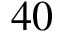<formula> <loc_0><loc_0><loc_500><loc_500>4 0</formula> 